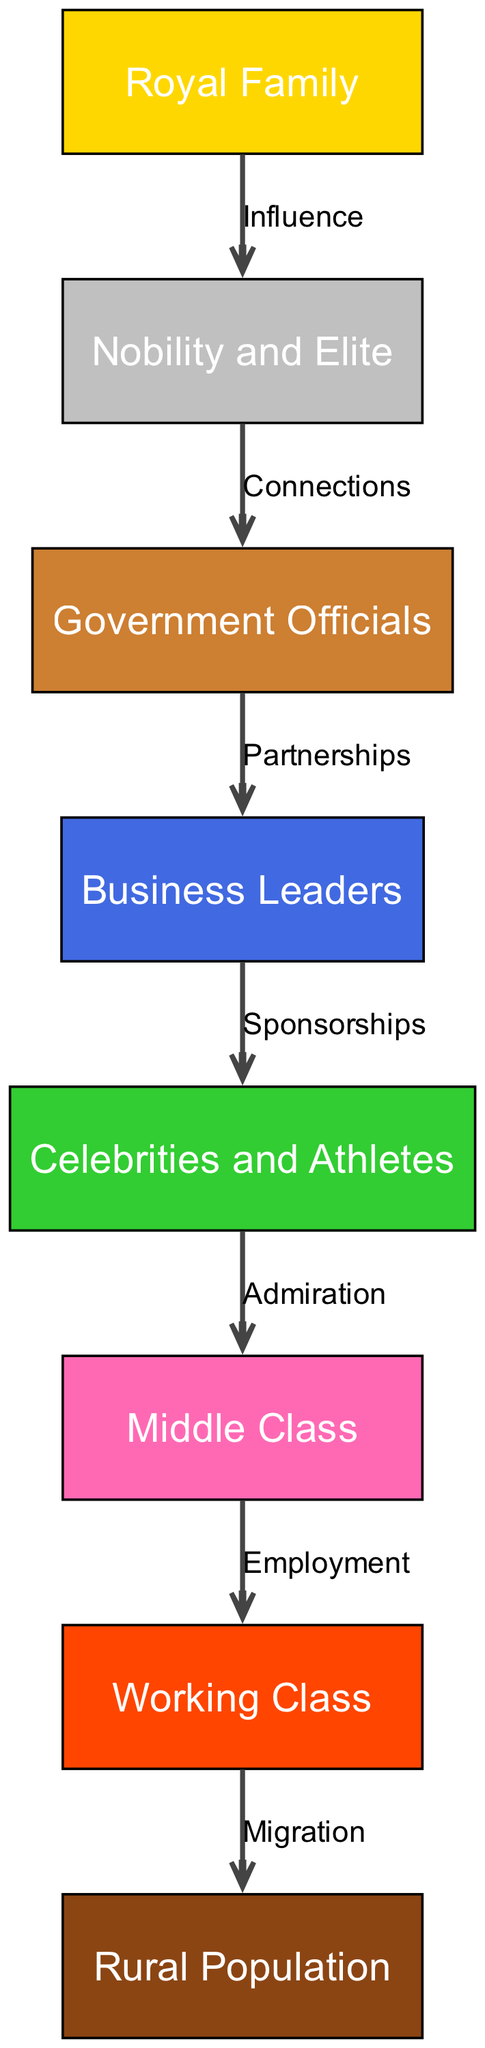What is the top node in the hierarchy? The top node in the hierarchy is the Royal Family, which is the most influential group in Thai society as shown in the diagram.
Answer: Royal Family How many nodes are there in the diagram? The diagram contains 8 nodes, each representing a different social class or group in Thai society, including the Royal Family and various classes.
Answer: 8 What is the relationship between Nobility and Government Officials? The relationship is defined by "Connections," indicating that the Nobility interacts closely with Government Officials, influencing decision-making and power structures.
Answer: Connections Who primarily influences the Business Leaders? Business Leaders are primarily influenced by Government Officials, as indicated by the edge labeled "Partnerships" connecting them.
Answer: Government Officials What group is directly below Celebrities and Athletes in the hierarchy? The Celebrities and Athletes group has a direct relationship with the Middle Class through admiration, showing its impact on social dynamics.
Answer: Middle Class Which social class is directly connected to the Working Class? The social class directly connected to the Working Class, according to the diagram, is the Middle Class, which employs individuals from the Working Class.
Answer: Middle Class In the flow from the Working Class, where do they migrate to? Individuals from the Working Class migrate to the Rural Population, indicating a movement pattern often seen when seeking better opportunities.
Answer: Rural Population What role do Business Leaders play in relation to Celebrities and Athletes? Business Leaders play a role of providing Sponsorships to Celebrities and Athletes, which boosts the latter’s visibility and opportunities within society.
Answer: Sponsorships How does the Middle Class influence the Working Class? The Middle Class influences the Working Class through Employment, which is a critical relationship that reflects economic dependencies in society.
Answer: Employment 